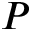<formula> <loc_0><loc_0><loc_500><loc_500>P</formula> 